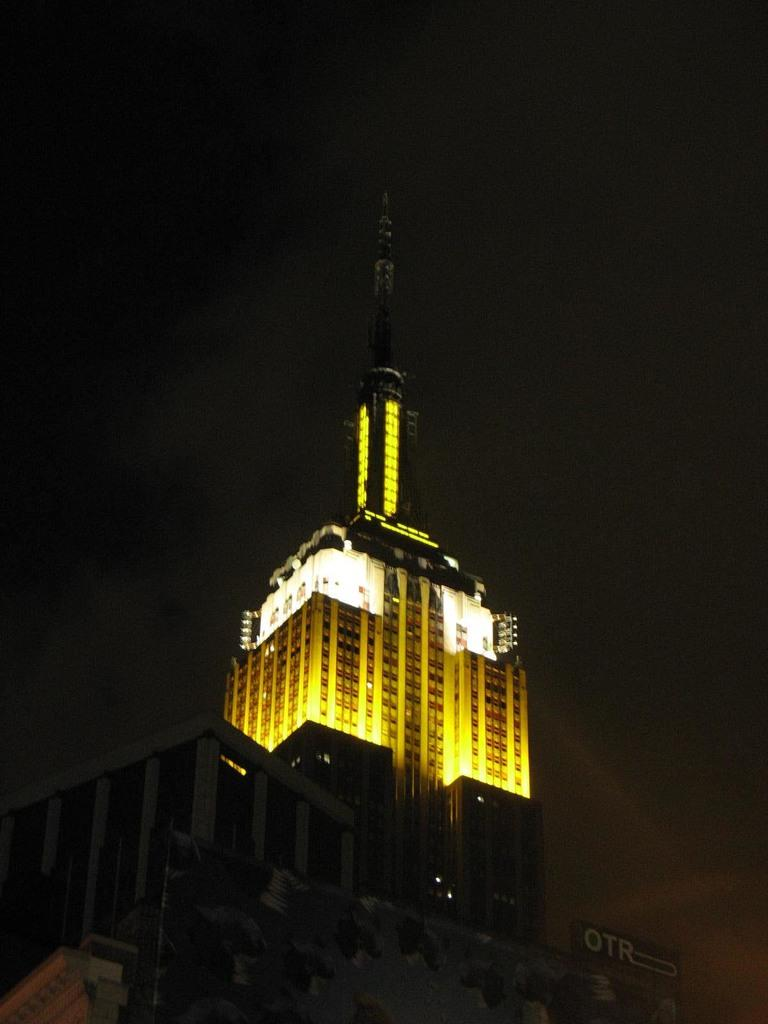What is the main structure in the image? There is a building in the image. What feature of the building is mentioned in the facts? The building has lights. What direction is the smoke coming from in the image? There is no smoke present in the image. Is the building located near the ocean in the image? The provided facts do not mention anything about the ocean, so we cannot determine if the building is near it. 